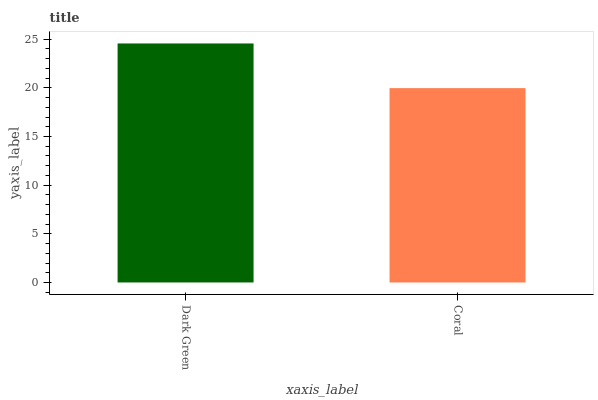Is Coral the minimum?
Answer yes or no. Yes. Is Dark Green the maximum?
Answer yes or no. Yes. Is Coral the maximum?
Answer yes or no. No. Is Dark Green greater than Coral?
Answer yes or no. Yes. Is Coral less than Dark Green?
Answer yes or no. Yes. Is Coral greater than Dark Green?
Answer yes or no. No. Is Dark Green less than Coral?
Answer yes or no. No. Is Dark Green the high median?
Answer yes or no. Yes. Is Coral the low median?
Answer yes or no. Yes. Is Coral the high median?
Answer yes or no. No. Is Dark Green the low median?
Answer yes or no. No. 